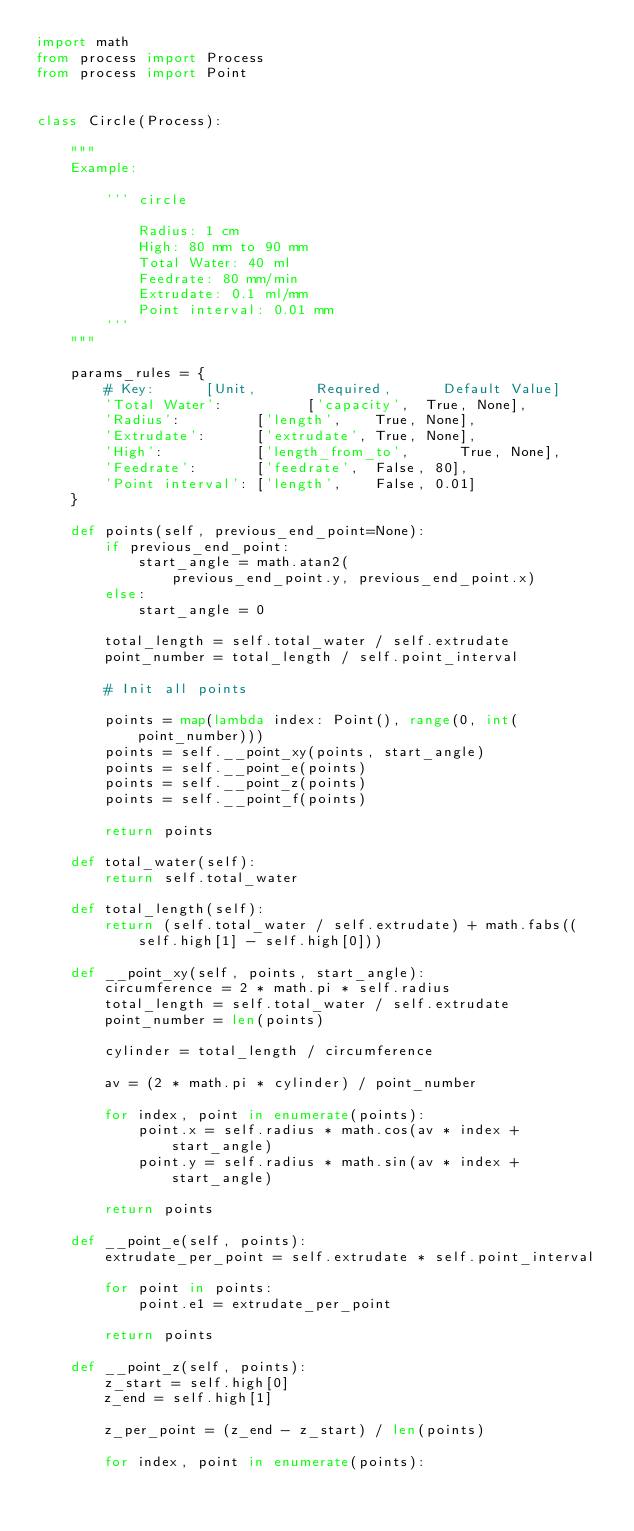<code> <loc_0><loc_0><loc_500><loc_500><_Python_>import math
from process import Process
from process import Point


class Circle(Process):

    """
    Example:

        ''' circle

            Radius: 1 cm
            High: 80 mm to 90 mm
            Total Water: 40 ml
            Feedrate: 80 mm/min
            Extrudate: 0.1 ml/mm
            Point interval: 0.01 mm
        '''
    """

    params_rules = {
        # Key:      [Unit,       Required,      Default Value]
        'Total Water':          ['capacity',  True, None],
        'Radius':         ['length',    True, None],
        'Extrudate':      ['extrudate', True, None],
        'High':           ['length_from_to',      True, None],
        'Feedrate':       ['feedrate',  False, 80],
        'Point interval': ['length',    False, 0.01]
    }

    def points(self, previous_end_point=None):
        if previous_end_point:
            start_angle = math.atan2(
                previous_end_point.y, previous_end_point.x)
        else:
            start_angle = 0

        total_length = self.total_water / self.extrudate
        point_number = total_length / self.point_interval

        # Init all points

        points = map(lambda index: Point(), range(0, int(point_number)))
        points = self.__point_xy(points, start_angle)
        points = self.__point_e(points)
        points = self.__point_z(points)
        points = self.__point_f(points)

        return points

    def total_water(self):
        return self.total_water

    def total_length(self):
        return (self.total_water / self.extrudate) + math.fabs((self.high[1] - self.high[0]))

    def __point_xy(self, points, start_angle):
        circumference = 2 * math.pi * self.radius
        total_length = self.total_water / self.extrudate
        point_number = len(points)

        cylinder = total_length / circumference

        av = (2 * math.pi * cylinder) / point_number

        for index, point in enumerate(points):
            point.x = self.radius * math.cos(av * index + start_angle)
            point.y = self.radius * math.sin(av * index + start_angle)

        return points

    def __point_e(self, points):
        extrudate_per_point = self.extrudate * self.point_interval

        for point in points:
            point.e1 = extrudate_per_point

        return points

    def __point_z(self, points):
        z_start = self.high[0]
        z_end = self.high[1]

        z_per_point = (z_end - z_start) / len(points)

        for index, point in enumerate(points):</code> 